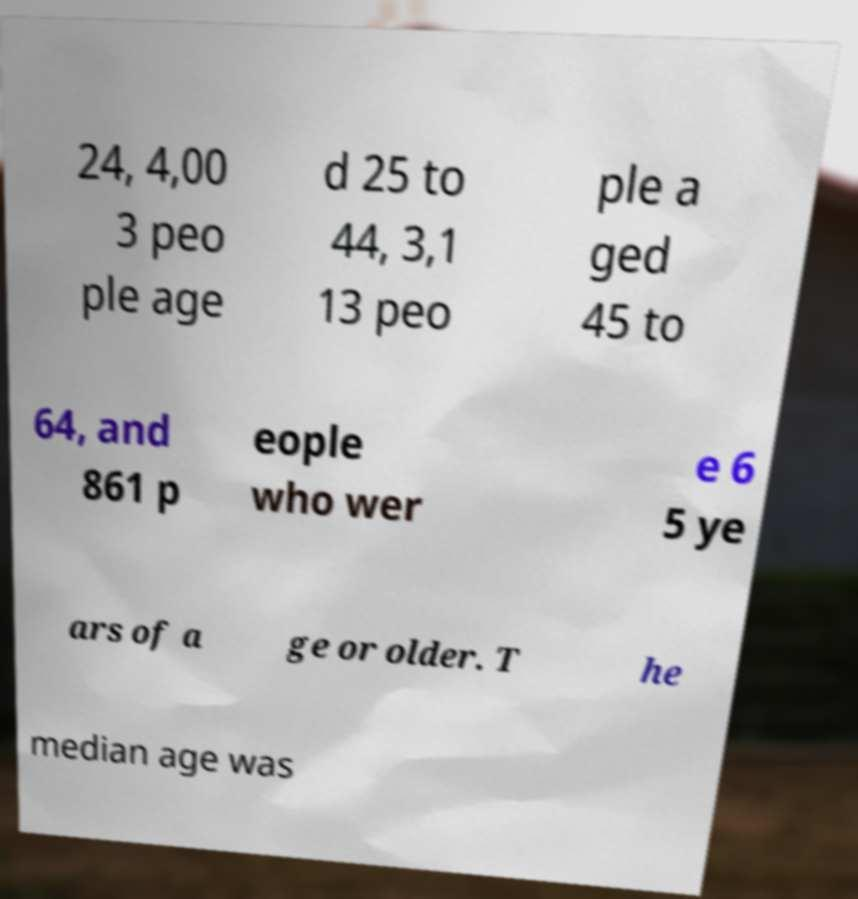For documentation purposes, I need the text within this image transcribed. Could you provide that? 24, 4,00 3 peo ple age d 25 to 44, 3,1 13 peo ple a ged 45 to 64, and 861 p eople who wer e 6 5 ye ars of a ge or older. T he median age was 